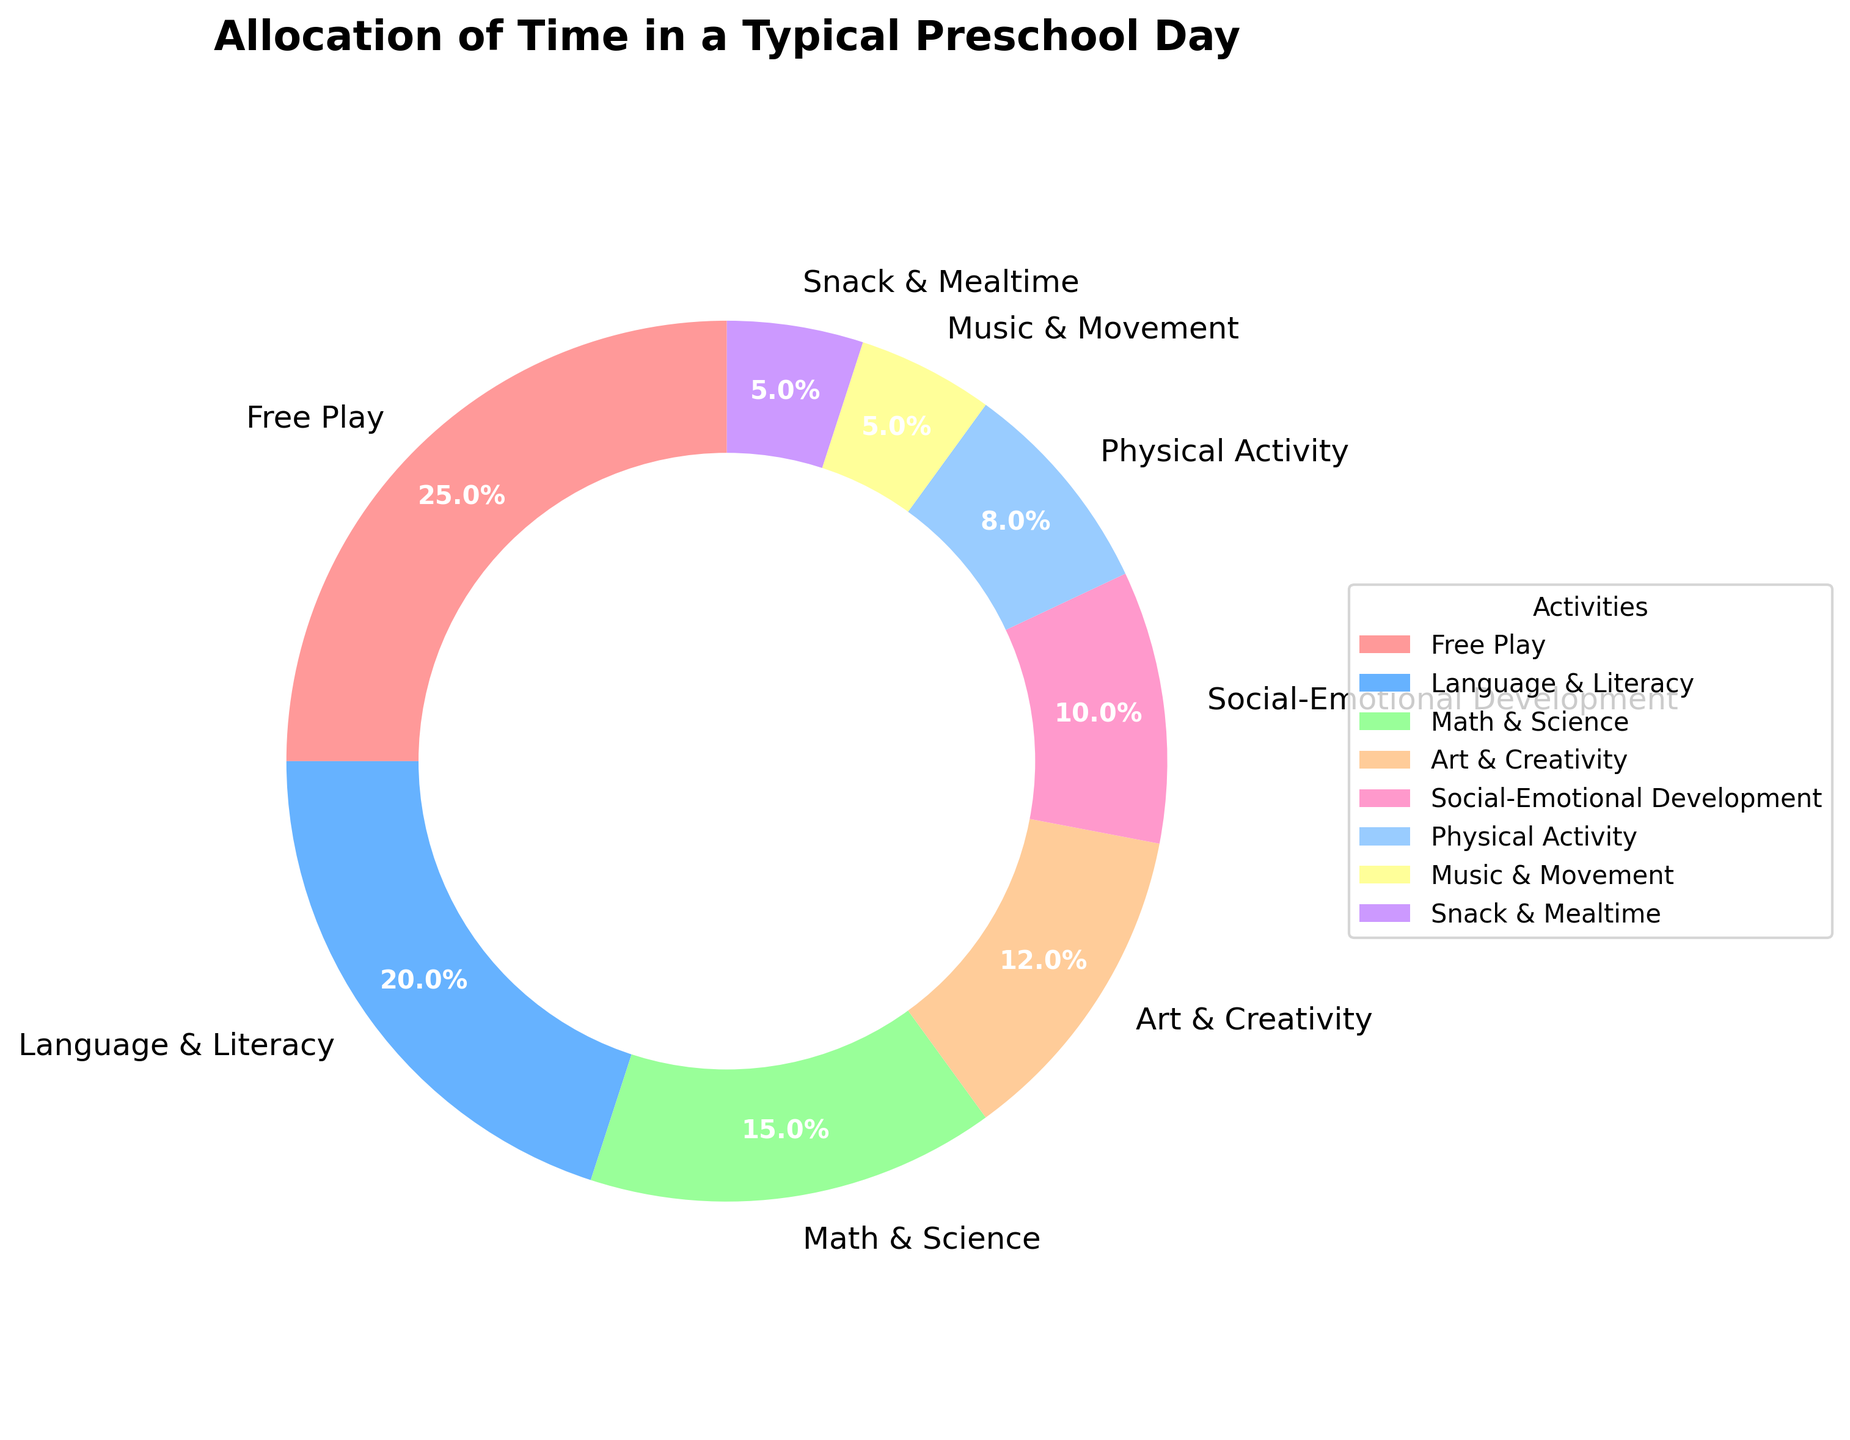What activity takes up the largest percentage of time? By examining the pie chart, we can see that the section labeled "Free Play" has the largest segment, encompassing 25% of the total time. Therefore, Free Play takes up the largest percentage of time.
Answer: Free Play Which activity is allotted the least amount of time? By checking the smallest segment of the pie chart, we can identify that "Music & Movement" and "Snack & Mealtime" each take up the smallest sections at 5% each. These activities are allotted the least amount of time.
Answer: Music & Movement and Snack & Mealtime What is the total percentage of time spent on Language & Literacy and Math & Science combined? Adding the percentages allocated for Language & Literacy (20%) and Math & Science (15%) gives us a total of 35%.
Answer: 35% Is the percentage of time spent on Physical Activity greater than Social-Emotional Development? By comparing the segments, Physical Activity accounts for 8% and Social-Emotional Development for 10%. Clearly, Social-Emotional Development has a greater percentage.
Answer: No How much more time is allocated to Art & Creativity compared to Snack & Mealtime? Art & Creativity takes up 12%, while Snack & Mealtime takes up 5%. Subtracting these gives 12% - 5% = 7%. Thus, Art & Creativity is allocated 7% more time.
Answer: 7% What percentage of the time is dedicated to activities other than Free Play? Free Play occupies 25% of the time. Subtracting this from 100% (total time) we get 100% - 25% = 75%. So, 75% of the time is dedicated to activities other than Free Play.
Answer: 75% Are there any two activities that take up equal percentages of time? By observing the pie chart, we notice that both Music & Movement and Snack & Mealtime each occupy 5% of the time, thus they take up equal percentages.
Answer: Yes What's the average percentage of time spent on the activities with the least and most time allocated? The least time is 5% (Music & Movement and Snack & Mealtime), and the most is 25% (Free Play). The average is calculated as (5% + 25%) / 2 = 15%.
Answer: 15% 